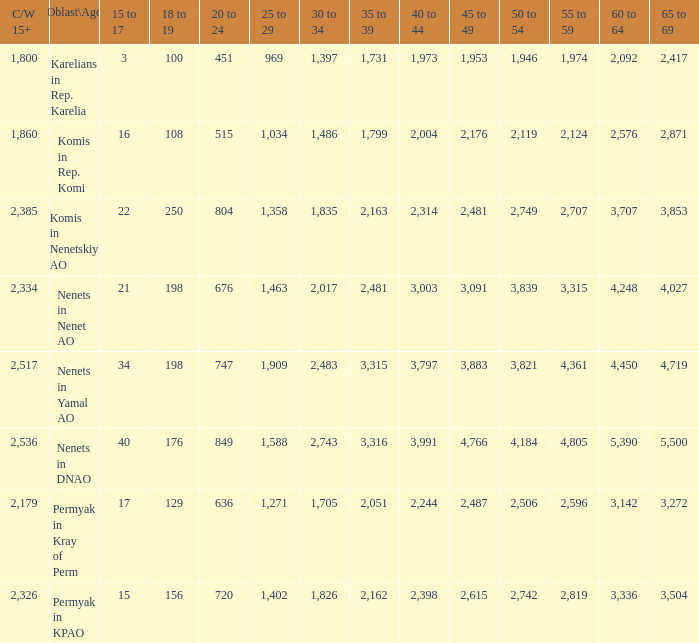Parse the table in full. {'header': ['C/W 15+', 'Oblast\\Age', '15 to 17', '18 to 19', '20 to 24', '25 to 29', '30 to 34', '35 to 39', '40 to 44', '45 to 49', '50 to 54', '55 to 59', '60 to 64', '65 to 69'], 'rows': [['1,800', 'Karelians in Rep. Karelia', '3', '100', '451', '969', '1,397', '1,731', '1,973', '1,953', '1,946', '1,974', '2,092', '2,417'], ['1,860', 'Komis in Rep. Komi', '16', '108', '515', '1,034', '1,486', '1,799', '2,004', '2,176', '2,119', '2,124', '2,576', '2,871'], ['2,385', 'Komis in Nenetskiy AO', '22', '250', '804', '1,358', '1,835', '2,163', '2,314', '2,481', '2,749', '2,707', '3,707', '3,853'], ['2,334', 'Nenets in Nenet AO', '21', '198', '676', '1,463', '2,017', '2,481', '3,003', '3,091', '3,839', '3,315', '4,248', '4,027'], ['2,517', 'Nenets in Yamal AO', '34', '198', '747', '1,909', '2,483', '3,315', '3,797', '3,883', '3,821', '4,361', '4,450', '4,719'], ['2,536', 'Nenets in DNAO', '40', '176', '849', '1,588', '2,743', '3,316', '3,991', '4,766', '4,184', '4,805', '5,390', '5,500'], ['2,179', 'Permyak in Kray of Perm', '17', '129', '636', '1,271', '1,705', '2,051', '2,244', '2,487', '2,506', '2,596', '3,142', '3,272'], ['2,326', 'Permyak in KPAO', '15', '156', '720', '1,402', '1,826', '2,162', '2,398', '2,615', '2,742', '2,819', '3,336', '3,504']]} What is the number of 40 to 44 when the 50 to 54 is less than 4,184, and the 15 to 17 is less than 3? 0.0. 